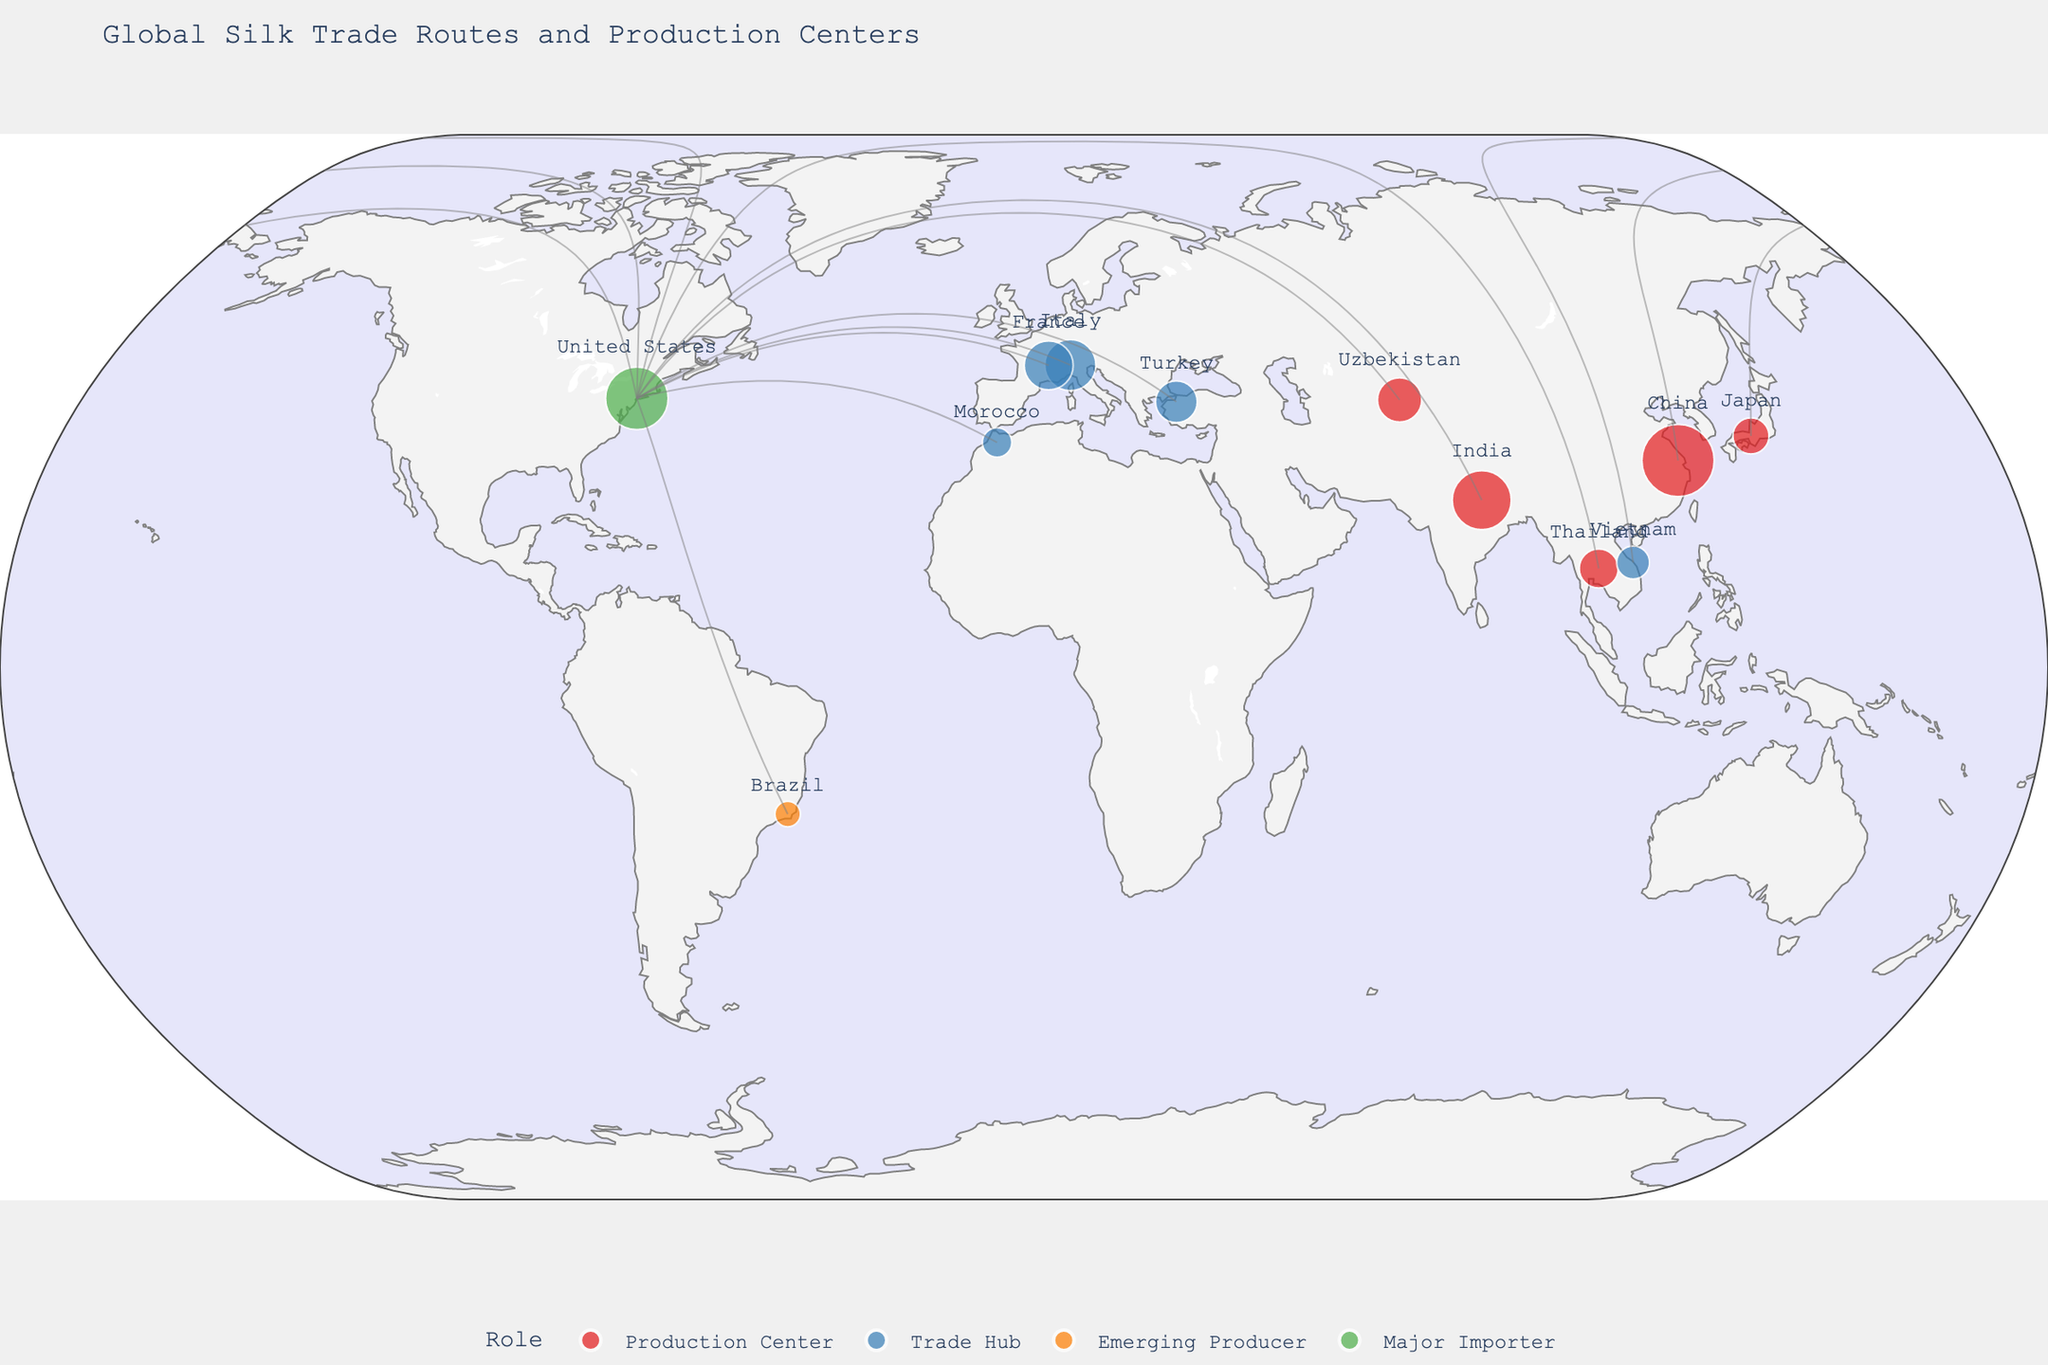Which country has the largest silk production center? By looking at the size of the bubbles on the map and the associated color codes, Suzhou in China stands out with the largest bubble, indicating the highest volume of silk production.
Answer: China How many production centers are shown on the map? By counting the number of red dots representing 'Production Centers' on the map, we can see four locations: Suzhou, Varanasi, Margilan, and Kyoto.
Answer: 4 Which city serves as a major importer of silk? By referring to the green dot on the map, we can identify New York City as the major importer of silk.
Answer: New York City What is the total volume of silk production from China and India? Extract the silk volumes for Suzhou (1200 tons) and Varanasi (800 tons) and sum them up: 1200 + 800 = 2000 tons.
Answer: 2000 tons Which trade hub has the least silk volume? By comparing the sizes of the blue dots representing 'Trade Hubs,' Fez in Morocco appears to have the smallest bubble, indicating the least volume of 200 tons.
Answer: Fez Does any production center produce less than 400 tons of silk? By examining and comparing the red dots on the map, Kyoto (300 tons) produces less than 400 tons.
Answer: Yes How many regions produce more silk than Italy's trade hub imports? Italy's trade hub (Como) imports 600 tons of silk. From the map, Suzhou, Varanasi, and New York City all exceed this amount. So, there are 3 regions.
Answer: 3 What is the combined volume of silk traded through the two Italian and French hubs? Summing the volumes for Como (600 tons) and Lyon (550 tons): 600 + 550 = 1150 tons.
Answer: 1150 tons Which city is marked as an 'Emerging Producer'? By looking for the orange dot representing 'Emerging Producer,' we can identify Nova Friburgo in Brazil.
Answer: Nova Friburgo 